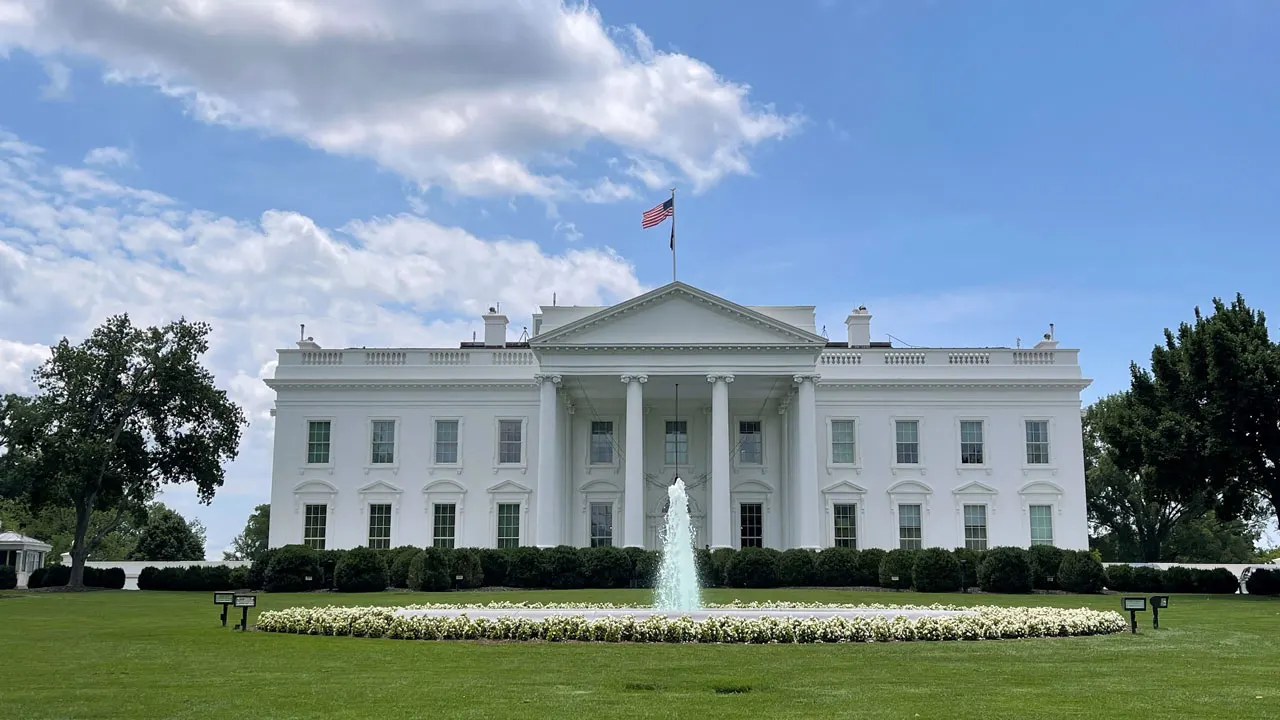If these walls could talk, what stories would the White House tell from its long history? Oh, the White House walls have witnessed innumerable pivotal moments and personal anecdotes throughout American history. From the excitement of inaugurations to the solemnity of moments during wars, the residence has been a backdrop to both public and private presidential lives. Imagine the early days when President John Adams moved in, the burning of the White House by British troops in 1814, and the rebuilding efforts by James Monroe. The walls have seen Lincoln's late-night musings during the Civil War and heard the deep conversations of Franklin D. Roosevelt during World War II. It would tell tales of the Cuban Missile Crisis meetings in the Oval Office with President Kennedy, and the dramatic moments leading to and following the Watergate Scandal under President Nixon. The residence has also been a family home - from the joy and laughter of children playing in its halls to the quieter, reflective moments of presidents and first families living within its storied confines. If you could add a futuristic element to the White House, what would it be and how would it integrate with its historical significance? Adding a futuristic element to the White House while respecting its historical significance is a fascinating challenge. One innovative yet seamless addition could be the integration of an advanced holographic communication room. This room would enable the President to hold virtual meetings with leaders and advisors from around the world, projecting life-sized, interactive holograms that make participants feel as though they are in the sharegpt4v/same room. To honor the building's historical significance, the room's design could incorporate classic elements like neoclassical columns and motifs, blending them with high-tech interfaces and displays. This fusion of past and future would symbolize the unity of tradition and progress, showing how the White House continues to evolve as both a seat of history and a beacon of modern leadership. 